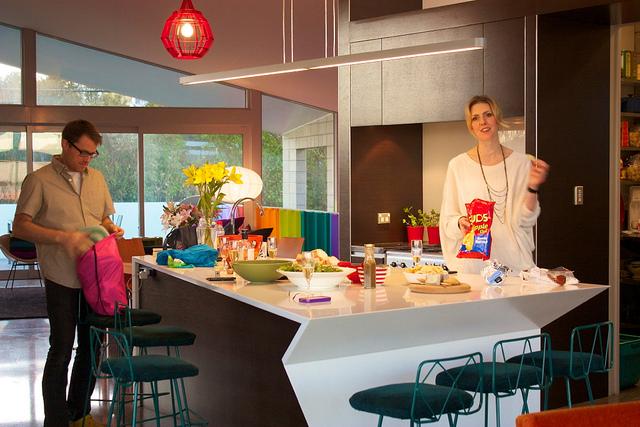Where are the bowls?
Give a very brief answer. Island counter. Is she a statue?
Give a very brief answer. No. Why is the girl so dressed up?
Be succinct. Party. How many different flowers are on the table?
Write a very short answer. 2. What color is his bag?
Quick response, please. Pink. 